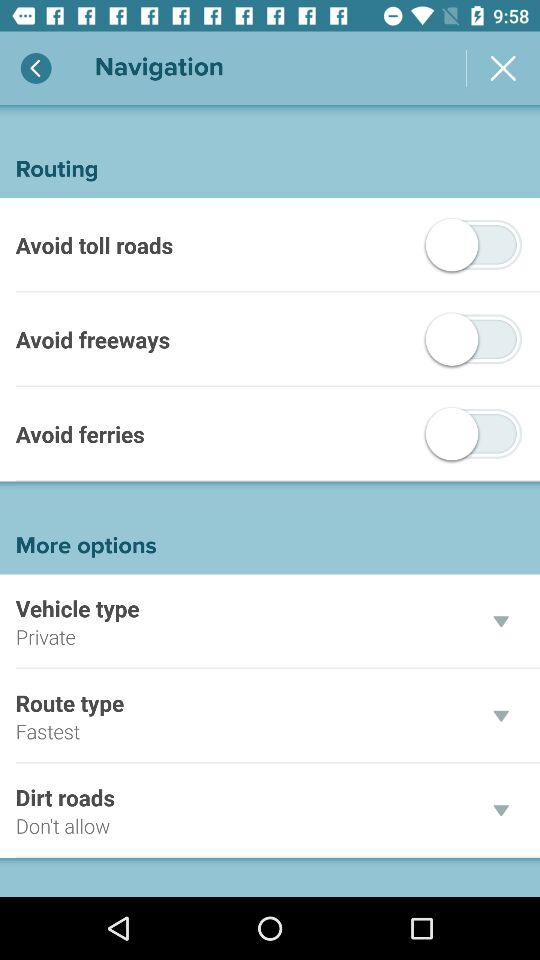How many 'More options' items are there?
Answer the question using a single word or phrase. 3 